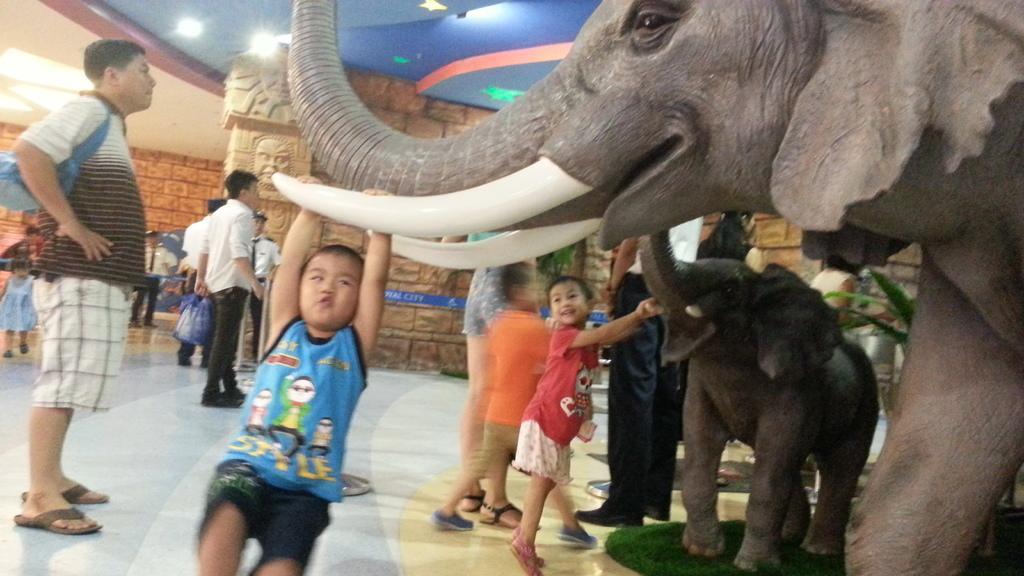How would you summarize this image in a sentence or two? This picture is of inside the hall. On the right there are sculptures of elephant and a calf. In the foreground we can see the children playing. On the left there is a man wearing a bag and standing. In the background we can see the roof, ceiling lights, brick wall and group of persons standing. 